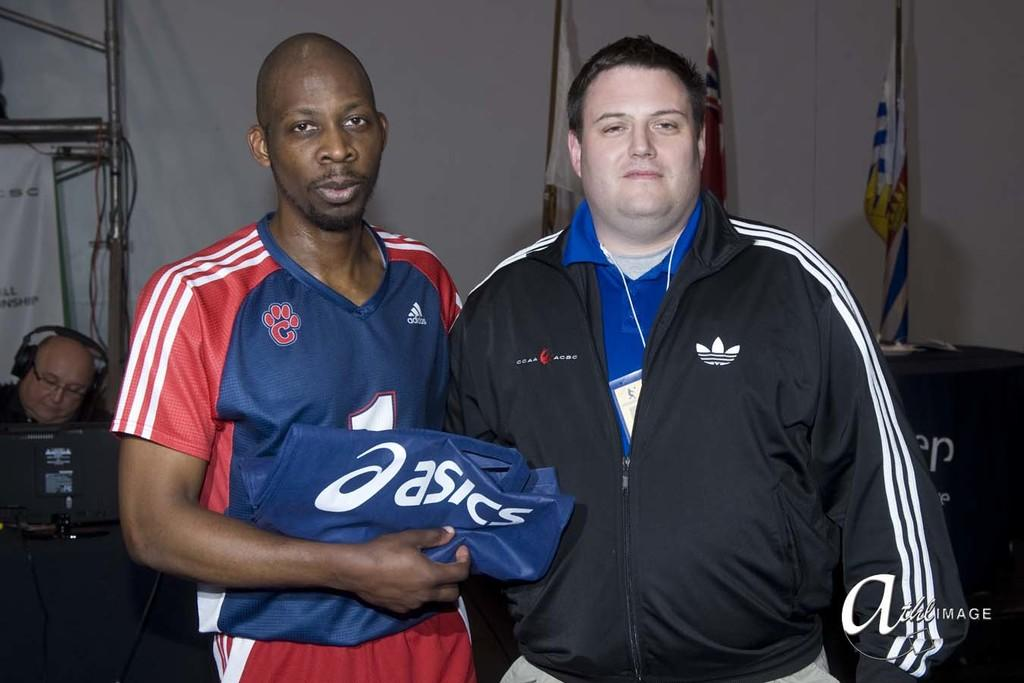<image>
Offer a succinct explanation of the picture presented. A man wearing a blue and red jersey holding a folded Asics cloth next to a chubby fellow with a black Adidas jacket. 